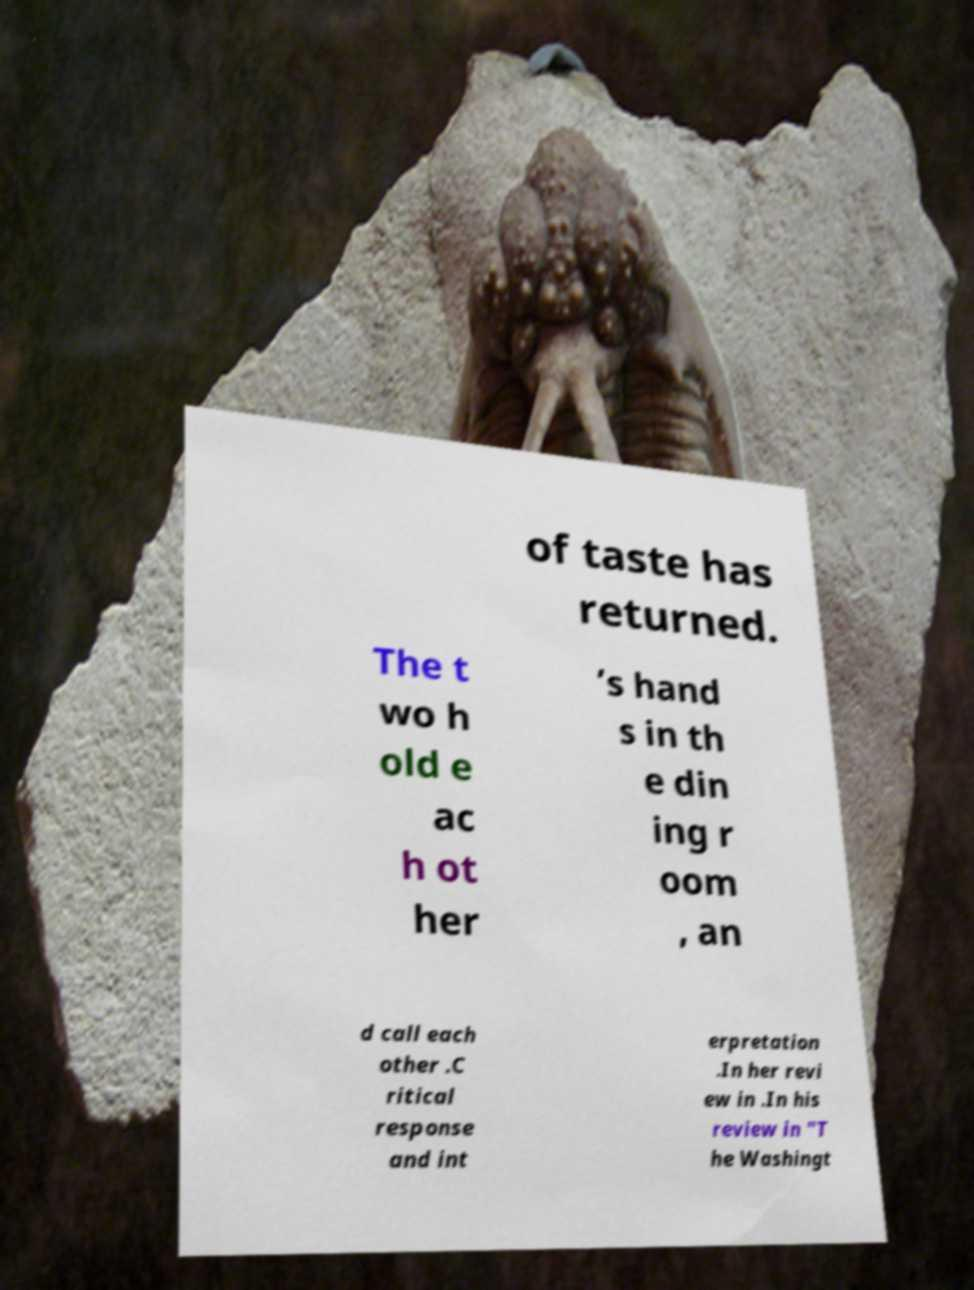Can you accurately transcribe the text from the provided image for me? of taste has returned. The t wo h old e ac h ot her ’s hand s in th e din ing r oom , an d call each other .C ritical response and int erpretation .In her revi ew in .In his review in "T he Washingt 